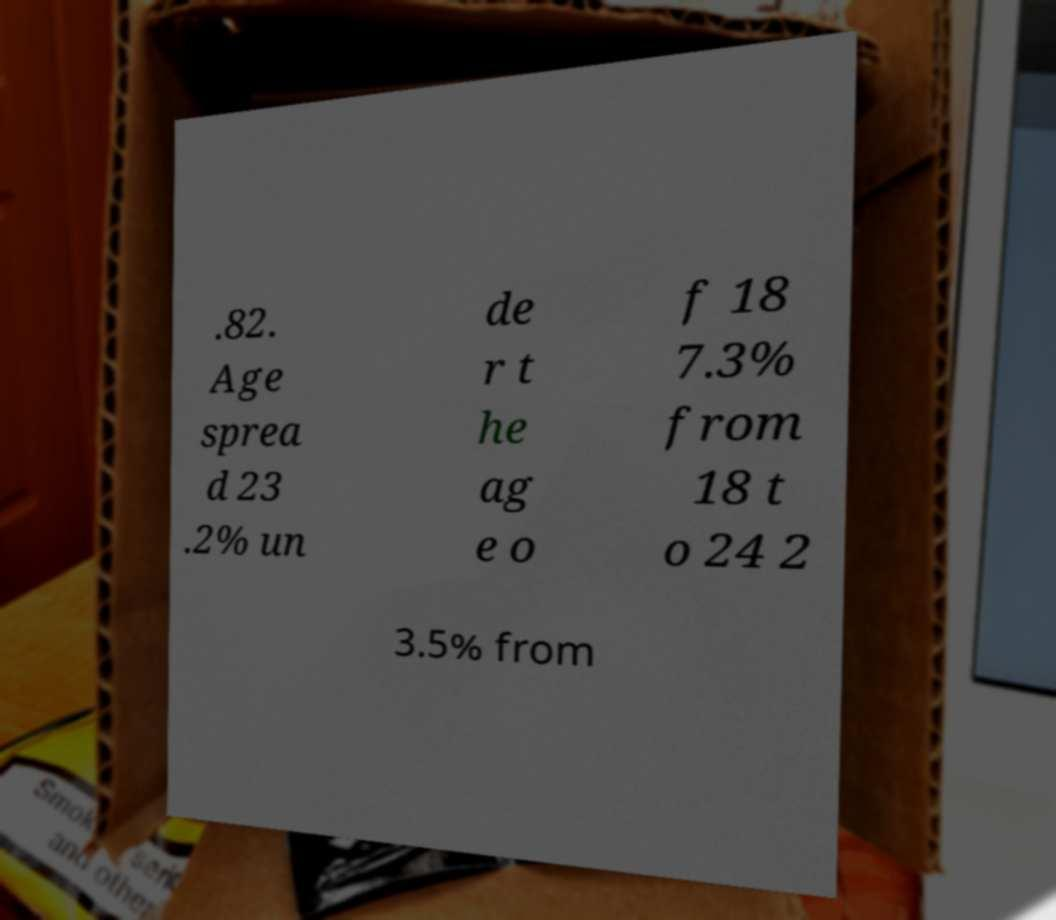There's text embedded in this image that I need extracted. Can you transcribe it verbatim? .82. Age sprea d 23 .2% un de r t he ag e o f 18 7.3% from 18 t o 24 2 3.5% from 